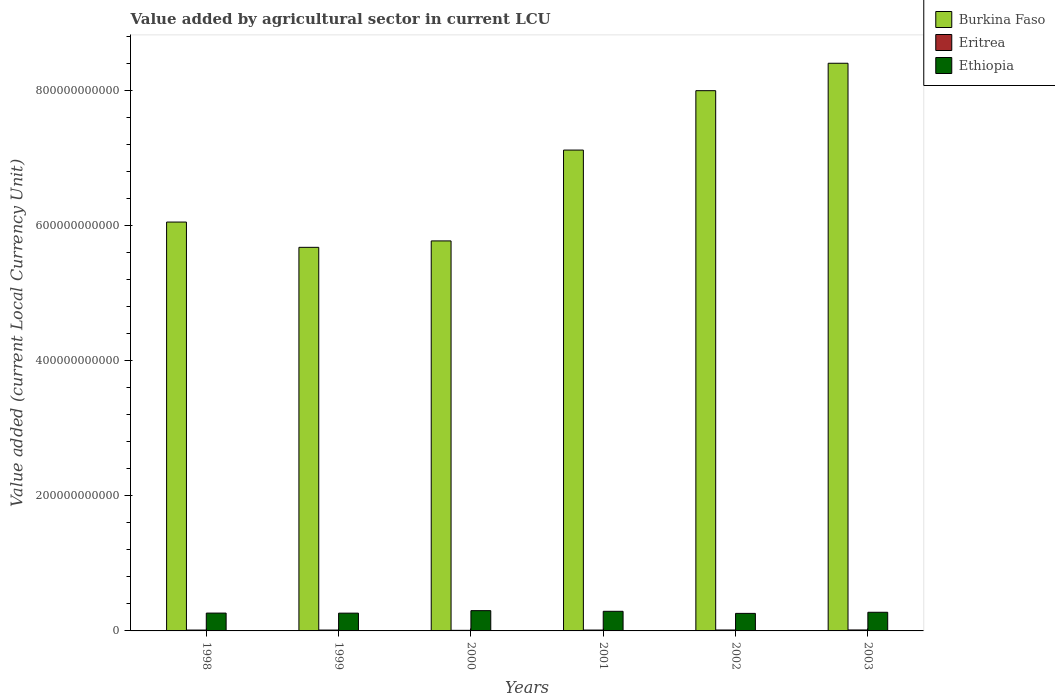Are the number of bars on each tick of the X-axis equal?
Offer a terse response. Yes. How many bars are there on the 3rd tick from the right?
Your answer should be very brief. 3. In how many cases, is the number of bars for a given year not equal to the number of legend labels?
Keep it short and to the point. 0. What is the value added by agricultural sector in Burkina Faso in 2001?
Your answer should be very brief. 7.12e+11. Across all years, what is the maximum value added by agricultural sector in Burkina Faso?
Provide a short and direct response. 8.40e+11. Across all years, what is the minimum value added by agricultural sector in Ethiopia?
Ensure brevity in your answer.  2.59e+1. What is the total value added by agricultural sector in Ethiopia in the graph?
Ensure brevity in your answer.  1.65e+11. What is the difference between the value added by agricultural sector in Burkina Faso in 1999 and that in 2000?
Your answer should be very brief. -9.49e+09. What is the difference between the value added by agricultural sector in Burkina Faso in 1998 and the value added by agricultural sector in Ethiopia in 2001?
Your response must be concise. 5.76e+11. What is the average value added by agricultural sector in Ethiopia per year?
Your answer should be very brief. 2.75e+1. In the year 2003, what is the difference between the value added by agricultural sector in Ethiopia and value added by agricultural sector in Burkina Faso?
Keep it short and to the point. -8.12e+11. What is the ratio of the value added by agricultural sector in Ethiopia in 1999 to that in 2001?
Make the answer very short. 0.91. Is the value added by agricultural sector in Ethiopia in 2001 less than that in 2003?
Your answer should be very brief. No. What is the difference between the highest and the second highest value added by agricultural sector in Burkina Faso?
Keep it short and to the point. 4.06e+1. What is the difference between the highest and the lowest value added by agricultural sector in Ethiopia?
Offer a very short reply. 4.05e+09. Is the sum of the value added by agricultural sector in Eritrea in 2000 and 2001 greater than the maximum value added by agricultural sector in Ethiopia across all years?
Provide a short and direct response. No. What does the 3rd bar from the left in 2002 represents?
Your answer should be very brief. Ethiopia. What does the 1st bar from the right in 2003 represents?
Offer a very short reply. Ethiopia. How many bars are there?
Offer a terse response. 18. Are all the bars in the graph horizontal?
Ensure brevity in your answer.  No. What is the difference between two consecutive major ticks on the Y-axis?
Offer a terse response. 2.00e+11. Are the values on the major ticks of Y-axis written in scientific E-notation?
Provide a succinct answer. No. Does the graph contain any zero values?
Your answer should be compact. No. Does the graph contain grids?
Your answer should be compact. No. Where does the legend appear in the graph?
Ensure brevity in your answer.  Top right. How many legend labels are there?
Your answer should be compact. 3. What is the title of the graph?
Keep it short and to the point. Value added by agricultural sector in current LCU. Does "Gabon" appear as one of the legend labels in the graph?
Provide a succinct answer. No. What is the label or title of the Y-axis?
Make the answer very short. Value added (current Local Currency Unit). What is the Value added (current Local Currency Unit) in Burkina Faso in 1998?
Give a very brief answer. 6.05e+11. What is the Value added (current Local Currency Unit) of Eritrea in 1998?
Keep it short and to the point. 1.28e+09. What is the Value added (current Local Currency Unit) of Ethiopia in 1998?
Give a very brief answer. 2.64e+1. What is the Value added (current Local Currency Unit) of Burkina Faso in 1999?
Keep it short and to the point. 5.68e+11. What is the Value added (current Local Currency Unit) in Eritrea in 1999?
Offer a terse response. 1.28e+09. What is the Value added (current Local Currency Unit) in Ethiopia in 1999?
Provide a succinct answer. 2.63e+1. What is the Value added (current Local Currency Unit) of Burkina Faso in 2000?
Your answer should be compact. 5.77e+11. What is the Value added (current Local Currency Unit) of Eritrea in 2000?
Ensure brevity in your answer.  8.56e+08. What is the Value added (current Local Currency Unit) in Ethiopia in 2000?
Keep it short and to the point. 3.00e+1. What is the Value added (current Local Currency Unit) of Burkina Faso in 2001?
Offer a terse response. 7.12e+11. What is the Value added (current Local Currency Unit) in Eritrea in 2001?
Offer a terse response. 1.29e+09. What is the Value added (current Local Currency Unit) in Ethiopia in 2001?
Provide a short and direct response. 2.90e+1. What is the Value added (current Local Currency Unit) in Burkina Faso in 2002?
Make the answer very short. 7.99e+11. What is the Value added (current Local Currency Unit) of Eritrea in 2002?
Ensure brevity in your answer.  1.38e+09. What is the Value added (current Local Currency Unit) of Ethiopia in 2002?
Your response must be concise. 2.59e+1. What is the Value added (current Local Currency Unit) in Burkina Faso in 2003?
Keep it short and to the point. 8.40e+11. What is the Value added (current Local Currency Unit) of Eritrea in 2003?
Give a very brief answer. 1.43e+09. What is the Value added (current Local Currency Unit) of Ethiopia in 2003?
Ensure brevity in your answer.  2.76e+1. Across all years, what is the maximum Value added (current Local Currency Unit) in Burkina Faso?
Provide a short and direct response. 8.40e+11. Across all years, what is the maximum Value added (current Local Currency Unit) of Eritrea?
Your answer should be compact. 1.43e+09. Across all years, what is the maximum Value added (current Local Currency Unit) in Ethiopia?
Give a very brief answer. 3.00e+1. Across all years, what is the minimum Value added (current Local Currency Unit) in Burkina Faso?
Your answer should be compact. 5.68e+11. Across all years, what is the minimum Value added (current Local Currency Unit) in Eritrea?
Ensure brevity in your answer.  8.56e+08. Across all years, what is the minimum Value added (current Local Currency Unit) of Ethiopia?
Make the answer very short. 2.59e+1. What is the total Value added (current Local Currency Unit) in Burkina Faso in the graph?
Your response must be concise. 4.10e+12. What is the total Value added (current Local Currency Unit) in Eritrea in the graph?
Keep it short and to the point. 7.52e+09. What is the total Value added (current Local Currency Unit) of Ethiopia in the graph?
Your response must be concise. 1.65e+11. What is the difference between the Value added (current Local Currency Unit) of Burkina Faso in 1998 and that in 1999?
Your response must be concise. 3.74e+1. What is the difference between the Value added (current Local Currency Unit) of Eritrea in 1998 and that in 1999?
Provide a short and direct response. 6.30e+06. What is the difference between the Value added (current Local Currency Unit) in Ethiopia in 1998 and that in 1999?
Give a very brief answer. 8.89e+07. What is the difference between the Value added (current Local Currency Unit) in Burkina Faso in 1998 and that in 2000?
Keep it short and to the point. 2.79e+1. What is the difference between the Value added (current Local Currency Unit) in Eritrea in 1998 and that in 2000?
Provide a short and direct response. 4.26e+08. What is the difference between the Value added (current Local Currency Unit) of Ethiopia in 1998 and that in 2000?
Your response must be concise. -3.60e+09. What is the difference between the Value added (current Local Currency Unit) in Burkina Faso in 1998 and that in 2001?
Your answer should be compact. -1.07e+11. What is the difference between the Value added (current Local Currency Unit) of Eritrea in 1998 and that in 2001?
Your response must be concise. -7.78e+06. What is the difference between the Value added (current Local Currency Unit) in Ethiopia in 1998 and that in 2001?
Make the answer very short. -2.63e+09. What is the difference between the Value added (current Local Currency Unit) of Burkina Faso in 1998 and that in 2002?
Give a very brief answer. -1.94e+11. What is the difference between the Value added (current Local Currency Unit) in Eritrea in 1998 and that in 2002?
Offer a terse response. -1.02e+08. What is the difference between the Value added (current Local Currency Unit) of Ethiopia in 1998 and that in 2002?
Keep it short and to the point. 4.48e+08. What is the difference between the Value added (current Local Currency Unit) of Burkina Faso in 1998 and that in 2003?
Your answer should be very brief. -2.35e+11. What is the difference between the Value added (current Local Currency Unit) of Eritrea in 1998 and that in 2003?
Your answer should be compact. -1.46e+08. What is the difference between the Value added (current Local Currency Unit) in Ethiopia in 1998 and that in 2003?
Your response must be concise. -1.19e+09. What is the difference between the Value added (current Local Currency Unit) of Burkina Faso in 1999 and that in 2000?
Your response must be concise. -9.49e+09. What is the difference between the Value added (current Local Currency Unit) in Eritrea in 1999 and that in 2000?
Give a very brief answer. 4.20e+08. What is the difference between the Value added (current Local Currency Unit) of Ethiopia in 1999 and that in 2000?
Give a very brief answer. -3.69e+09. What is the difference between the Value added (current Local Currency Unit) of Burkina Faso in 1999 and that in 2001?
Your answer should be compact. -1.44e+11. What is the difference between the Value added (current Local Currency Unit) of Eritrea in 1999 and that in 2001?
Your answer should be compact. -1.41e+07. What is the difference between the Value added (current Local Currency Unit) in Ethiopia in 1999 and that in 2001?
Provide a succinct answer. -2.72e+09. What is the difference between the Value added (current Local Currency Unit) of Burkina Faso in 1999 and that in 2002?
Make the answer very short. -2.32e+11. What is the difference between the Value added (current Local Currency Unit) of Eritrea in 1999 and that in 2002?
Keep it short and to the point. -1.08e+08. What is the difference between the Value added (current Local Currency Unit) in Ethiopia in 1999 and that in 2002?
Provide a short and direct response. 3.59e+08. What is the difference between the Value added (current Local Currency Unit) in Burkina Faso in 1999 and that in 2003?
Offer a very short reply. -2.72e+11. What is the difference between the Value added (current Local Currency Unit) of Eritrea in 1999 and that in 2003?
Provide a succinct answer. -1.53e+08. What is the difference between the Value added (current Local Currency Unit) in Ethiopia in 1999 and that in 2003?
Keep it short and to the point. -1.28e+09. What is the difference between the Value added (current Local Currency Unit) of Burkina Faso in 2000 and that in 2001?
Offer a terse response. -1.34e+11. What is the difference between the Value added (current Local Currency Unit) of Eritrea in 2000 and that in 2001?
Offer a terse response. -4.34e+08. What is the difference between the Value added (current Local Currency Unit) of Ethiopia in 2000 and that in 2001?
Your answer should be compact. 9.74e+08. What is the difference between the Value added (current Local Currency Unit) in Burkina Faso in 2000 and that in 2002?
Offer a very short reply. -2.22e+11. What is the difference between the Value added (current Local Currency Unit) in Eritrea in 2000 and that in 2002?
Provide a short and direct response. -5.29e+08. What is the difference between the Value added (current Local Currency Unit) in Ethiopia in 2000 and that in 2002?
Ensure brevity in your answer.  4.05e+09. What is the difference between the Value added (current Local Currency Unit) of Burkina Faso in 2000 and that in 2003?
Keep it short and to the point. -2.63e+11. What is the difference between the Value added (current Local Currency Unit) in Eritrea in 2000 and that in 2003?
Make the answer very short. -5.73e+08. What is the difference between the Value added (current Local Currency Unit) in Ethiopia in 2000 and that in 2003?
Ensure brevity in your answer.  2.41e+09. What is the difference between the Value added (current Local Currency Unit) in Burkina Faso in 2001 and that in 2002?
Provide a short and direct response. -8.79e+1. What is the difference between the Value added (current Local Currency Unit) in Eritrea in 2001 and that in 2002?
Provide a short and direct response. -9.44e+07. What is the difference between the Value added (current Local Currency Unit) of Ethiopia in 2001 and that in 2002?
Offer a terse response. 3.07e+09. What is the difference between the Value added (current Local Currency Unit) in Burkina Faso in 2001 and that in 2003?
Your answer should be compact. -1.28e+11. What is the difference between the Value added (current Local Currency Unit) of Eritrea in 2001 and that in 2003?
Ensure brevity in your answer.  -1.38e+08. What is the difference between the Value added (current Local Currency Unit) of Ethiopia in 2001 and that in 2003?
Ensure brevity in your answer.  1.43e+09. What is the difference between the Value added (current Local Currency Unit) of Burkina Faso in 2002 and that in 2003?
Offer a very short reply. -4.06e+1. What is the difference between the Value added (current Local Currency Unit) in Eritrea in 2002 and that in 2003?
Make the answer very short. -4.41e+07. What is the difference between the Value added (current Local Currency Unit) in Ethiopia in 2002 and that in 2003?
Make the answer very short. -1.64e+09. What is the difference between the Value added (current Local Currency Unit) in Burkina Faso in 1998 and the Value added (current Local Currency Unit) in Eritrea in 1999?
Ensure brevity in your answer.  6.04e+11. What is the difference between the Value added (current Local Currency Unit) in Burkina Faso in 1998 and the Value added (current Local Currency Unit) in Ethiopia in 1999?
Make the answer very short. 5.79e+11. What is the difference between the Value added (current Local Currency Unit) of Eritrea in 1998 and the Value added (current Local Currency Unit) of Ethiopia in 1999?
Your response must be concise. -2.50e+1. What is the difference between the Value added (current Local Currency Unit) in Burkina Faso in 1998 and the Value added (current Local Currency Unit) in Eritrea in 2000?
Your answer should be compact. 6.04e+11. What is the difference between the Value added (current Local Currency Unit) of Burkina Faso in 1998 and the Value added (current Local Currency Unit) of Ethiopia in 2000?
Offer a very short reply. 5.75e+11. What is the difference between the Value added (current Local Currency Unit) in Eritrea in 1998 and the Value added (current Local Currency Unit) in Ethiopia in 2000?
Your answer should be compact. -2.87e+1. What is the difference between the Value added (current Local Currency Unit) of Burkina Faso in 1998 and the Value added (current Local Currency Unit) of Eritrea in 2001?
Give a very brief answer. 6.04e+11. What is the difference between the Value added (current Local Currency Unit) of Burkina Faso in 1998 and the Value added (current Local Currency Unit) of Ethiopia in 2001?
Give a very brief answer. 5.76e+11. What is the difference between the Value added (current Local Currency Unit) in Eritrea in 1998 and the Value added (current Local Currency Unit) in Ethiopia in 2001?
Offer a terse response. -2.77e+1. What is the difference between the Value added (current Local Currency Unit) of Burkina Faso in 1998 and the Value added (current Local Currency Unit) of Eritrea in 2002?
Provide a succinct answer. 6.04e+11. What is the difference between the Value added (current Local Currency Unit) in Burkina Faso in 1998 and the Value added (current Local Currency Unit) in Ethiopia in 2002?
Keep it short and to the point. 5.79e+11. What is the difference between the Value added (current Local Currency Unit) in Eritrea in 1998 and the Value added (current Local Currency Unit) in Ethiopia in 2002?
Give a very brief answer. -2.47e+1. What is the difference between the Value added (current Local Currency Unit) of Burkina Faso in 1998 and the Value added (current Local Currency Unit) of Eritrea in 2003?
Ensure brevity in your answer.  6.04e+11. What is the difference between the Value added (current Local Currency Unit) of Burkina Faso in 1998 and the Value added (current Local Currency Unit) of Ethiopia in 2003?
Provide a short and direct response. 5.77e+11. What is the difference between the Value added (current Local Currency Unit) in Eritrea in 1998 and the Value added (current Local Currency Unit) in Ethiopia in 2003?
Ensure brevity in your answer.  -2.63e+1. What is the difference between the Value added (current Local Currency Unit) of Burkina Faso in 1999 and the Value added (current Local Currency Unit) of Eritrea in 2000?
Give a very brief answer. 5.67e+11. What is the difference between the Value added (current Local Currency Unit) of Burkina Faso in 1999 and the Value added (current Local Currency Unit) of Ethiopia in 2000?
Provide a succinct answer. 5.38e+11. What is the difference between the Value added (current Local Currency Unit) of Eritrea in 1999 and the Value added (current Local Currency Unit) of Ethiopia in 2000?
Give a very brief answer. -2.87e+1. What is the difference between the Value added (current Local Currency Unit) in Burkina Faso in 1999 and the Value added (current Local Currency Unit) in Eritrea in 2001?
Your response must be concise. 5.66e+11. What is the difference between the Value added (current Local Currency Unit) in Burkina Faso in 1999 and the Value added (current Local Currency Unit) in Ethiopia in 2001?
Your response must be concise. 5.39e+11. What is the difference between the Value added (current Local Currency Unit) in Eritrea in 1999 and the Value added (current Local Currency Unit) in Ethiopia in 2001?
Offer a very short reply. -2.77e+1. What is the difference between the Value added (current Local Currency Unit) of Burkina Faso in 1999 and the Value added (current Local Currency Unit) of Eritrea in 2002?
Your answer should be very brief. 5.66e+11. What is the difference between the Value added (current Local Currency Unit) of Burkina Faso in 1999 and the Value added (current Local Currency Unit) of Ethiopia in 2002?
Give a very brief answer. 5.42e+11. What is the difference between the Value added (current Local Currency Unit) of Eritrea in 1999 and the Value added (current Local Currency Unit) of Ethiopia in 2002?
Offer a terse response. -2.47e+1. What is the difference between the Value added (current Local Currency Unit) of Burkina Faso in 1999 and the Value added (current Local Currency Unit) of Eritrea in 2003?
Make the answer very short. 5.66e+11. What is the difference between the Value added (current Local Currency Unit) in Burkina Faso in 1999 and the Value added (current Local Currency Unit) in Ethiopia in 2003?
Ensure brevity in your answer.  5.40e+11. What is the difference between the Value added (current Local Currency Unit) in Eritrea in 1999 and the Value added (current Local Currency Unit) in Ethiopia in 2003?
Your answer should be very brief. -2.63e+1. What is the difference between the Value added (current Local Currency Unit) of Burkina Faso in 2000 and the Value added (current Local Currency Unit) of Eritrea in 2001?
Offer a terse response. 5.76e+11. What is the difference between the Value added (current Local Currency Unit) in Burkina Faso in 2000 and the Value added (current Local Currency Unit) in Ethiopia in 2001?
Offer a terse response. 5.48e+11. What is the difference between the Value added (current Local Currency Unit) of Eritrea in 2000 and the Value added (current Local Currency Unit) of Ethiopia in 2001?
Offer a very short reply. -2.82e+1. What is the difference between the Value added (current Local Currency Unit) in Burkina Faso in 2000 and the Value added (current Local Currency Unit) in Eritrea in 2002?
Give a very brief answer. 5.76e+11. What is the difference between the Value added (current Local Currency Unit) in Burkina Faso in 2000 and the Value added (current Local Currency Unit) in Ethiopia in 2002?
Your answer should be very brief. 5.51e+11. What is the difference between the Value added (current Local Currency Unit) in Eritrea in 2000 and the Value added (current Local Currency Unit) in Ethiopia in 2002?
Give a very brief answer. -2.51e+1. What is the difference between the Value added (current Local Currency Unit) in Burkina Faso in 2000 and the Value added (current Local Currency Unit) in Eritrea in 2003?
Keep it short and to the point. 5.76e+11. What is the difference between the Value added (current Local Currency Unit) in Burkina Faso in 2000 and the Value added (current Local Currency Unit) in Ethiopia in 2003?
Ensure brevity in your answer.  5.50e+11. What is the difference between the Value added (current Local Currency Unit) in Eritrea in 2000 and the Value added (current Local Currency Unit) in Ethiopia in 2003?
Provide a succinct answer. -2.67e+1. What is the difference between the Value added (current Local Currency Unit) in Burkina Faso in 2001 and the Value added (current Local Currency Unit) in Eritrea in 2002?
Keep it short and to the point. 7.10e+11. What is the difference between the Value added (current Local Currency Unit) of Burkina Faso in 2001 and the Value added (current Local Currency Unit) of Ethiopia in 2002?
Keep it short and to the point. 6.86e+11. What is the difference between the Value added (current Local Currency Unit) in Eritrea in 2001 and the Value added (current Local Currency Unit) in Ethiopia in 2002?
Your answer should be compact. -2.47e+1. What is the difference between the Value added (current Local Currency Unit) of Burkina Faso in 2001 and the Value added (current Local Currency Unit) of Eritrea in 2003?
Provide a short and direct response. 7.10e+11. What is the difference between the Value added (current Local Currency Unit) in Burkina Faso in 2001 and the Value added (current Local Currency Unit) in Ethiopia in 2003?
Provide a short and direct response. 6.84e+11. What is the difference between the Value added (current Local Currency Unit) in Eritrea in 2001 and the Value added (current Local Currency Unit) in Ethiopia in 2003?
Offer a terse response. -2.63e+1. What is the difference between the Value added (current Local Currency Unit) of Burkina Faso in 2002 and the Value added (current Local Currency Unit) of Eritrea in 2003?
Provide a succinct answer. 7.98e+11. What is the difference between the Value added (current Local Currency Unit) of Burkina Faso in 2002 and the Value added (current Local Currency Unit) of Ethiopia in 2003?
Give a very brief answer. 7.72e+11. What is the difference between the Value added (current Local Currency Unit) of Eritrea in 2002 and the Value added (current Local Currency Unit) of Ethiopia in 2003?
Your answer should be compact. -2.62e+1. What is the average Value added (current Local Currency Unit) in Burkina Faso per year?
Give a very brief answer. 6.83e+11. What is the average Value added (current Local Currency Unit) in Eritrea per year?
Your response must be concise. 1.25e+09. What is the average Value added (current Local Currency Unit) in Ethiopia per year?
Your answer should be compact. 2.75e+1. In the year 1998, what is the difference between the Value added (current Local Currency Unit) of Burkina Faso and Value added (current Local Currency Unit) of Eritrea?
Make the answer very short. 6.04e+11. In the year 1998, what is the difference between the Value added (current Local Currency Unit) of Burkina Faso and Value added (current Local Currency Unit) of Ethiopia?
Your answer should be very brief. 5.79e+11. In the year 1998, what is the difference between the Value added (current Local Currency Unit) of Eritrea and Value added (current Local Currency Unit) of Ethiopia?
Provide a short and direct response. -2.51e+1. In the year 1999, what is the difference between the Value added (current Local Currency Unit) of Burkina Faso and Value added (current Local Currency Unit) of Eritrea?
Keep it short and to the point. 5.66e+11. In the year 1999, what is the difference between the Value added (current Local Currency Unit) of Burkina Faso and Value added (current Local Currency Unit) of Ethiopia?
Provide a short and direct response. 5.41e+11. In the year 1999, what is the difference between the Value added (current Local Currency Unit) of Eritrea and Value added (current Local Currency Unit) of Ethiopia?
Offer a very short reply. -2.50e+1. In the year 2000, what is the difference between the Value added (current Local Currency Unit) of Burkina Faso and Value added (current Local Currency Unit) of Eritrea?
Offer a terse response. 5.76e+11. In the year 2000, what is the difference between the Value added (current Local Currency Unit) of Burkina Faso and Value added (current Local Currency Unit) of Ethiopia?
Offer a very short reply. 5.47e+11. In the year 2000, what is the difference between the Value added (current Local Currency Unit) in Eritrea and Value added (current Local Currency Unit) in Ethiopia?
Provide a succinct answer. -2.91e+1. In the year 2001, what is the difference between the Value added (current Local Currency Unit) in Burkina Faso and Value added (current Local Currency Unit) in Eritrea?
Provide a short and direct response. 7.10e+11. In the year 2001, what is the difference between the Value added (current Local Currency Unit) of Burkina Faso and Value added (current Local Currency Unit) of Ethiopia?
Offer a very short reply. 6.83e+11. In the year 2001, what is the difference between the Value added (current Local Currency Unit) of Eritrea and Value added (current Local Currency Unit) of Ethiopia?
Give a very brief answer. -2.77e+1. In the year 2002, what is the difference between the Value added (current Local Currency Unit) of Burkina Faso and Value added (current Local Currency Unit) of Eritrea?
Ensure brevity in your answer.  7.98e+11. In the year 2002, what is the difference between the Value added (current Local Currency Unit) in Burkina Faso and Value added (current Local Currency Unit) in Ethiopia?
Ensure brevity in your answer.  7.73e+11. In the year 2002, what is the difference between the Value added (current Local Currency Unit) of Eritrea and Value added (current Local Currency Unit) of Ethiopia?
Make the answer very short. -2.46e+1. In the year 2003, what is the difference between the Value added (current Local Currency Unit) in Burkina Faso and Value added (current Local Currency Unit) in Eritrea?
Offer a very short reply. 8.39e+11. In the year 2003, what is the difference between the Value added (current Local Currency Unit) of Burkina Faso and Value added (current Local Currency Unit) of Ethiopia?
Provide a short and direct response. 8.12e+11. In the year 2003, what is the difference between the Value added (current Local Currency Unit) of Eritrea and Value added (current Local Currency Unit) of Ethiopia?
Your answer should be very brief. -2.62e+1. What is the ratio of the Value added (current Local Currency Unit) in Burkina Faso in 1998 to that in 1999?
Your answer should be very brief. 1.07. What is the ratio of the Value added (current Local Currency Unit) in Eritrea in 1998 to that in 1999?
Provide a short and direct response. 1. What is the ratio of the Value added (current Local Currency Unit) of Ethiopia in 1998 to that in 1999?
Ensure brevity in your answer.  1. What is the ratio of the Value added (current Local Currency Unit) of Burkina Faso in 1998 to that in 2000?
Give a very brief answer. 1.05. What is the ratio of the Value added (current Local Currency Unit) of Eritrea in 1998 to that in 2000?
Give a very brief answer. 1.5. What is the ratio of the Value added (current Local Currency Unit) in Ethiopia in 1998 to that in 2000?
Offer a terse response. 0.88. What is the ratio of the Value added (current Local Currency Unit) in Burkina Faso in 1998 to that in 2001?
Your answer should be very brief. 0.85. What is the ratio of the Value added (current Local Currency Unit) of Ethiopia in 1998 to that in 2001?
Make the answer very short. 0.91. What is the ratio of the Value added (current Local Currency Unit) of Burkina Faso in 1998 to that in 2002?
Give a very brief answer. 0.76. What is the ratio of the Value added (current Local Currency Unit) in Eritrea in 1998 to that in 2002?
Make the answer very short. 0.93. What is the ratio of the Value added (current Local Currency Unit) in Ethiopia in 1998 to that in 2002?
Give a very brief answer. 1.02. What is the ratio of the Value added (current Local Currency Unit) in Burkina Faso in 1998 to that in 2003?
Ensure brevity in your answer.  0.72. What is the ratio of the Value added (current Local Currency Unit) of Eritrea in 1998 to that in 2003?
Offer a terse response. 0.9. What is the ratio of the Value added (current Local Currency Unit) of Ethiopia in 1998 to that in 2003?
Give a very brief answer. 0.96. What is the ratio of the Value added (current Local Currency Unit) of Burkina Faso in 1999 to that in 2000?
Offer a terse response. 0.98. What is the ratio of the Value added (current Local Currency Unit) of Eritrea in 1999 to that in 2000?
Offer a terse response. 1.49. What is the ratio of the Value added (current Local Currency Unit) of Ethiopia in 1999 to that in 2000?
Your answer should be very brief. 0.88. What is the ratio of the Value added (current Local Currency Unit) of Burkina Faso in 1999 to that in 2001?
Provide a succinct answer. 0.8. What is the ratio of the Value added (current Local Currency Unit) of Ethiopia in 1999 to that in 2001?
Provide a short and direct response. 0.91. What is the ratio of the Value added (current Local Currency Unit) in Burkina Faso in 1999 to that in 2002?
Give a very brief answer. 0.71. What is the ratio of the Value added (current Local Currency Unit) in Eritrea in 1999 to that in 2002?
Provide a succinct answer. 0.92. What is the ratio of the Value added (current Local Currency Unit) of Ethiopia in 1999 to that in 2002?
Offer a terse response. 1.01. What is the ratio of the Value added (current Local Currency Unit) of Burkina Faso in 1999 to that in 2003?
Provide a succinct answer. 0.68. What is the ratio of the Value added (current Local Currency Unit) of Eritrea in 1999 to that in 2003?
Offer a terse response. 0.89. What is the ratio of the Value added (current Local Currency Unit) in Ethiopia in 1999 to that in 2003?
Make the answer very short. 0.95. What is the ratio of the Value added (current Local Currency Unit) of Burkina Faso in 2000 to that in 2001?
Offer a terse response. 0.81. What is the ratio of the Value added (current Local Currency Unit) of Eritrea in 2000 to that in 2001?
Your response must be concise. 0.66. What is the ratio of the Value added (current Local Currency Unit) in Ethiopia in 2000 to that in 2001?
Keep it short and to the point. 1.03. What is the ratio of the Value added (current Local Currency Unit) of Burkina Faso in 2000 to that in 2002?
Your response must be concise. 0.72. What is the ratio of the Value added (current Local Currency Unit) of Eritrea in 2000 to that in 2002?
Your answer should be very brief. 0.62. What is the ratio of the Value added (current Local Currency Unit) of Ethiopia in 2000 to that in 2002?
Your answer should be compact. 1.16. What is the ratio of the Value added (current Local Currency Unit) of Burkina Faso in 2000 to that in 2003?
Give a very brief answer. 0.69. What is the ratio of the Value added (current Local Currency Unit) of Eritrea in 2000 to that in 2003?
Your answer should be very brief. 0.6. What is the ratio of the Value added (current Local Currency Unit) of Ethiopia in 2000 to that in 2003?
Give a very brief answer. 1.09. What is the ratio of the Value added (current Local Currency Unit) of Burkina Faso in 2001 to that in 2002?
Offer a very short reply. 0.89. What is the ratio of the Value added (current Local Currency Unit) of Eritrea in 2001 to that in 2002?
Provide a short and direct response. 0.93. What is the ratio of the Value added (current Local Currency Unit) in Ethiopia in 2001 to that in 2002?
Provide a succinct answer. 1.12. What is the ratio of the Value added (current Local Currency Unit) of Burkina Faso in 2001 to that in 2003?
Offer a very short reply. 0.85. What is the ratio of the Value added (current Local Currency Unit) in Eritrea in 2001 to that in 2003?
Ensure brevity in your answer.  0.9. What is the ratio of the Value added (current Local Currency Unit) in Ethiopia in 2001 to that in 2003?
Give a very brief answer. 1.05. What is the ratio of the Value added (current Local Currency Unit) of Burkina Faso in 2002 to that in 2003?
Your response must be concise. 0.95. What is the ratio of the Value added (current Local Currency Unit) of Eritrea in 2002 to that in 2003?
Provide a succinct answer. 0.97. What is the ratio of the Value added (current Local Currency Unit) in Ethiopia in 2002 to that in 2003?
Offer a terse response. 0.94. What is the difference between the highest and the second highest Value added (current Local Currency Unit) of Burkina Faso?
Ensure brevity in your answer.  4.06e+1. What is the difference between the highest and the second highest Value added (current Local Currency Unit) in Eritrea?
Your response must be concise. 4.41e+07. What is the difference between the highest and the second highest Value added (current Local Currency Unit) of Ethiopia?
Offer a terse response. 9.74e+08. What is the difference between the highest and the lowest Value added (current Local Currency Unit) of Burkina Faso?
Your response must be concise. 2.72e+11. What is the difference between the highest and the lowest Value added (current Local Currency Unit) of Eritrea?
Your answer should be very brief. 5.73e+08. What is the difference between the highest and the lowest Value added (current Local Currency Unit) in Ethiopia?
Provide a short and direct response. 4.05e+09. 